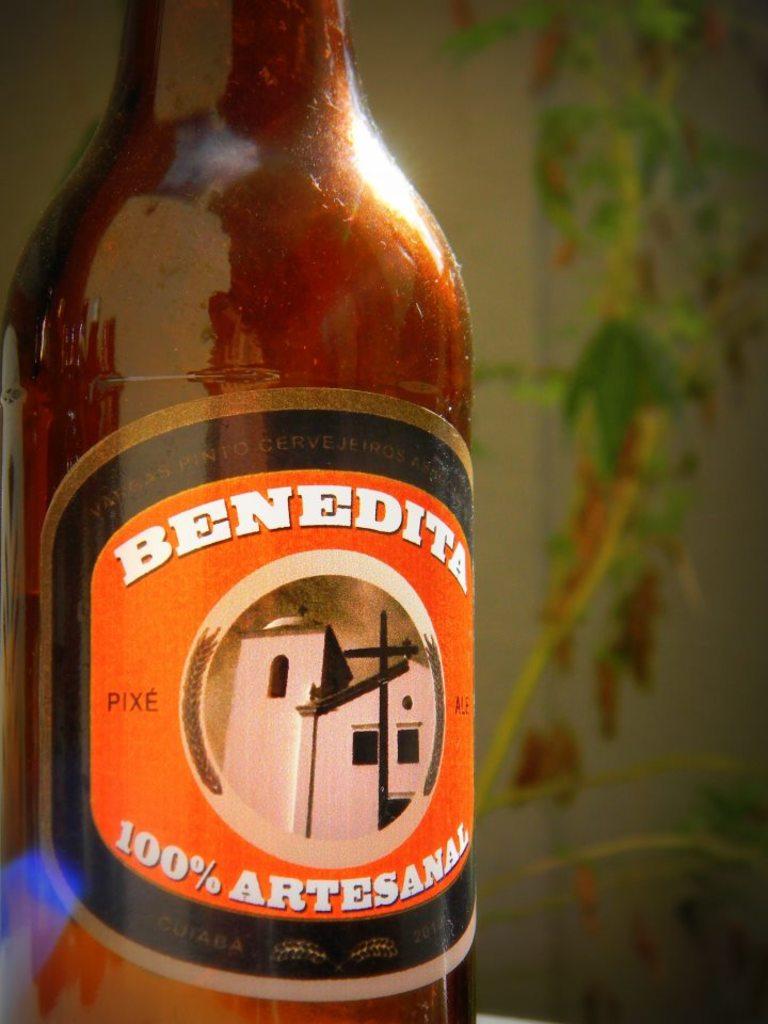This bottle is 100% what?
Provide a short and direct response. Artesanal. What is the pbrand of beer?
Offer a very short reply. Benedita. 